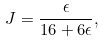Convert formula to latex. <formula><loc_0><loc_0><loc_500><loc_500>J = \frac { \epsilon } { 1 6 + 6 \epsilon } ,</formula> 